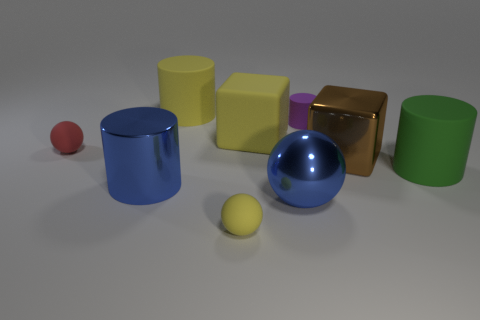Subtract all yellow spheres. How many spheres are left? 2 Subtract all matte cylinders. How many cylinders are left? 1 Subtract all cubes. How many objects are left? 7 Subtract 1 cylinders. How many cylinders are left? 3 Subtract all cyan blocks. How many red spheres are left? 1 Subtract all blue matte objects. Subtract all yellow rubber spheres. How many objects are left? 8 Add 2 yellow matte cylinders. How many yellow matte cylinders are left? 3 Add 6 matte balls. How many matte balls exist? 8 Subtract 0 green spheres. How many objects are left? 9 Subtract all purple spheres. Subtract all green cubes. How many spheres are left? 3 